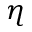Convert formula to latex. <formula><loc_0><loc_0><loc_500><loc_500>\eta</formula> 